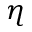Convert formula to latex. <formula><loc_0><loc_0><loc_500><loc_500>\eta</formula> 